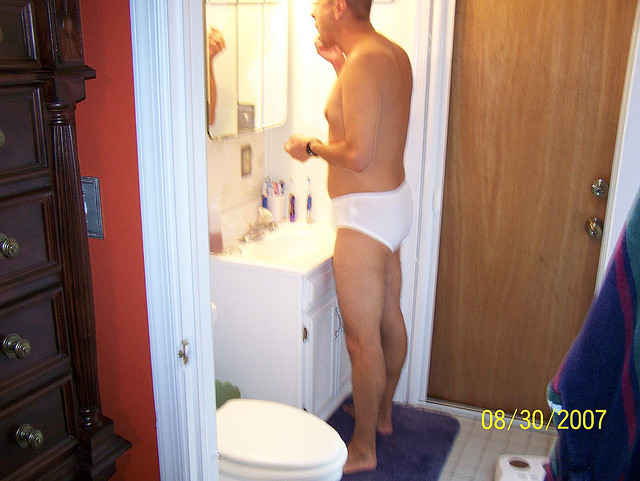<image>What is the man holding in his hands? I don't know what the man is holding in his hands. It could be a razor, toothbrush, floss, or toothpick. What is the man holding in his hands? I am not sure what the man is holding in his hands. It could be any of the mentioned items. 